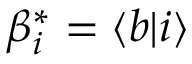<formula> <loc_0><loc_0><loc_500><loc_500>\beta _ { i } ^ { * } = \langle b | i \rangle</formula> 